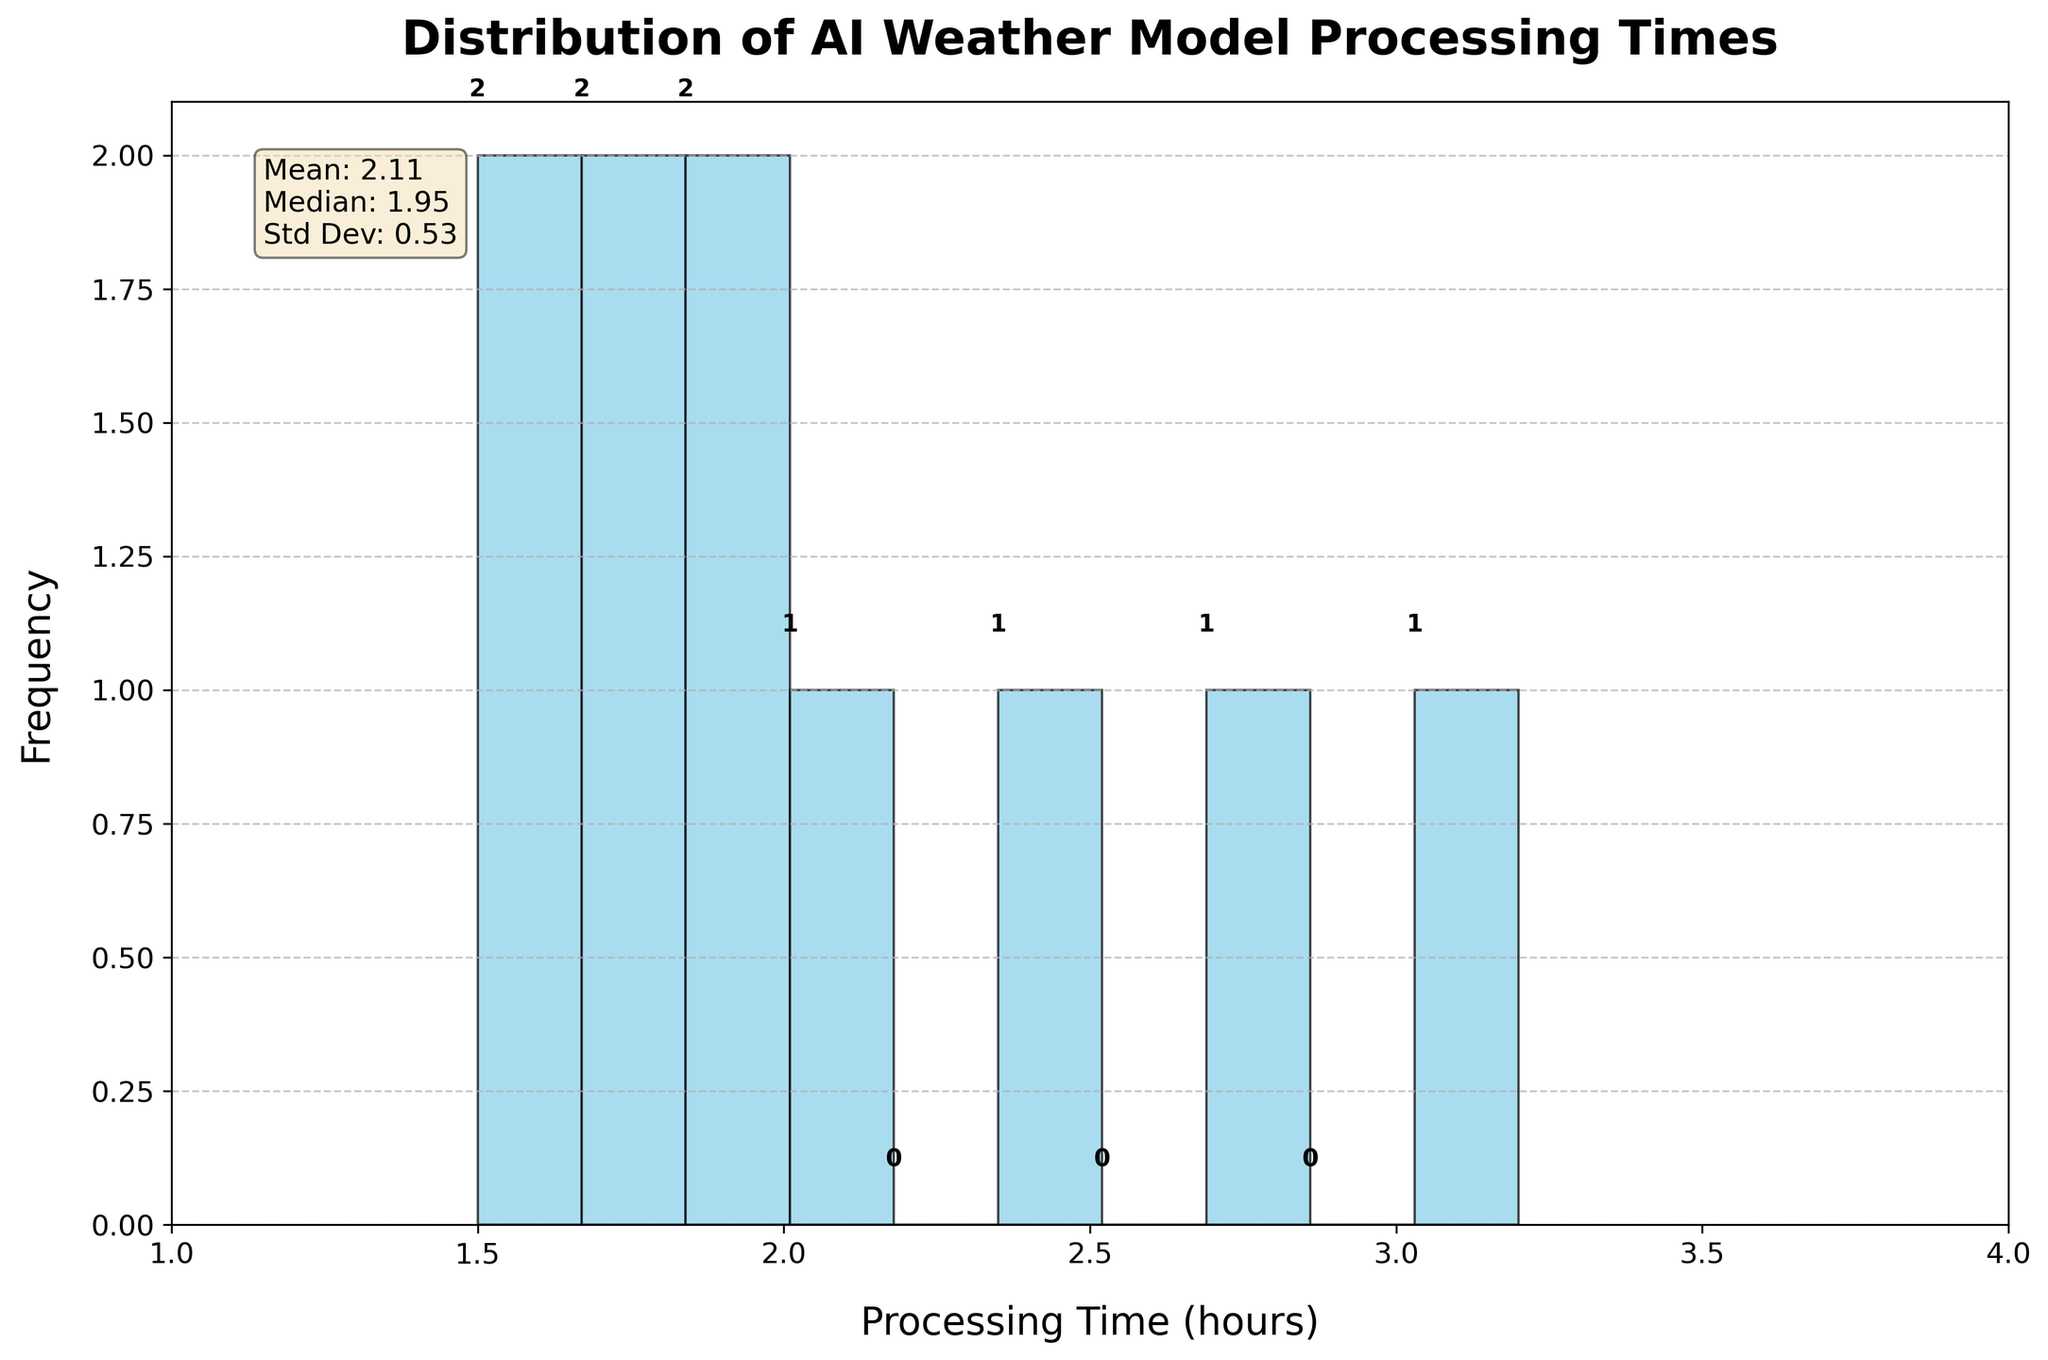What is the mean processing time for the AI weather models? The histogram contains a text box with statistics, which mentions that the mean processing time for the models is 2.11 hours.
Answer: 2.11 hours How many models have processing times under 2 hours? By inspecting the histogram bins, we can identify the number of data points (models) that fall within the range of 1.0 to 2.0 hours. There are 5 models in this range.
Answer: 5 models Which model has the lowest processing time? Each bin represents a range of processing times. The lowest processing time appears to fall in the first bin (1.5 hours), thus the model with the lowest processing time is identified within that bin. From the data, it is the Google DeepMind Storm model.
Answer: Google DeepMind Storm What is the distribution of processing times depicted in the histogram? The histogram shows a right-skewed distribution with more models having lower processing times (between 1.5 to 2.5 hours) and fewer models having higher processing times (above 2.5 hours).
Answer: Right-skewed distribution What is the range of processing times displayed in the histogram? The x-axis of the histogram ranges from 1 to 4 hours, indicating that the processing times of the models fall within this interval.
Answer: 1 to 4 hours What is the frequency of models having a processing time between 2.0 and 2.5 hours? The histogram's bin between 2.0 to 2.5 hours shows a frequency of 3 models, as noted directly above the bin.
Answer: 3 models Is the median processing time higher or lower than the mean processing time? The text box in the histogram provides both the mean (2.11 hours) and the median (2.00 hours). Comparing these values shows the median is slightly lower than the mean.
Answer: Lower How many bins are present in the histogram? By counting the vertical bars in the histogram, we can see there are 10 bins in total.
Answer: 10 bins Which models are represented in bins with a frequency of 1? Inspecting the histogram, bins containing only one model each are marked. From these, the corresponding data points (models) based on their processing times are: NOAA GFS (3.2 hours), Met Office UM (2.8 hours).
Answer: NOAA GFS, Met Office UM 